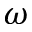Convert formula to latex. <formula><loc_0><loc_0><loc_500><loc_500>\omega</formula> 